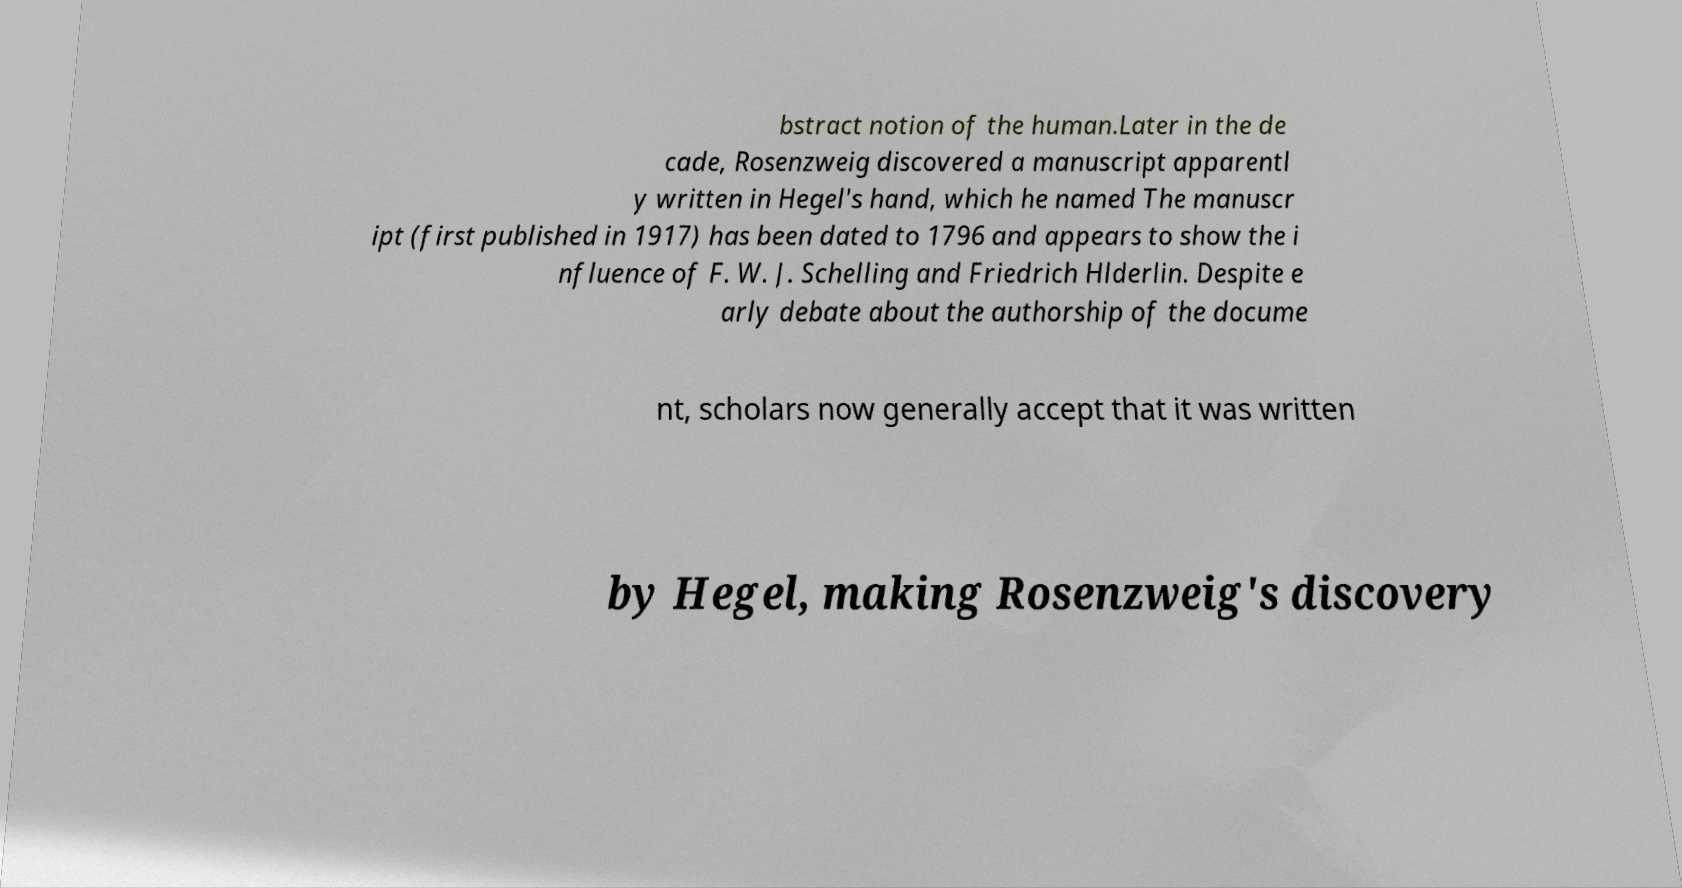Please identify and transcribe the text found in this image. bstract notion of the human.Later in the de cade, Rosenzweig discovered a manuscript apparentl y written in Hegel's hand, which he named The manuscr ipt (first published in 1917) has been dated to 1796 and appears to show the i nfluence of F. W. J. Schelling and Friedrich Hlderlin. Despite e arly debate about the authorship of the docume nt, scholars now generally accept that it was written by Hegel, making Rosenzweig's discovery 